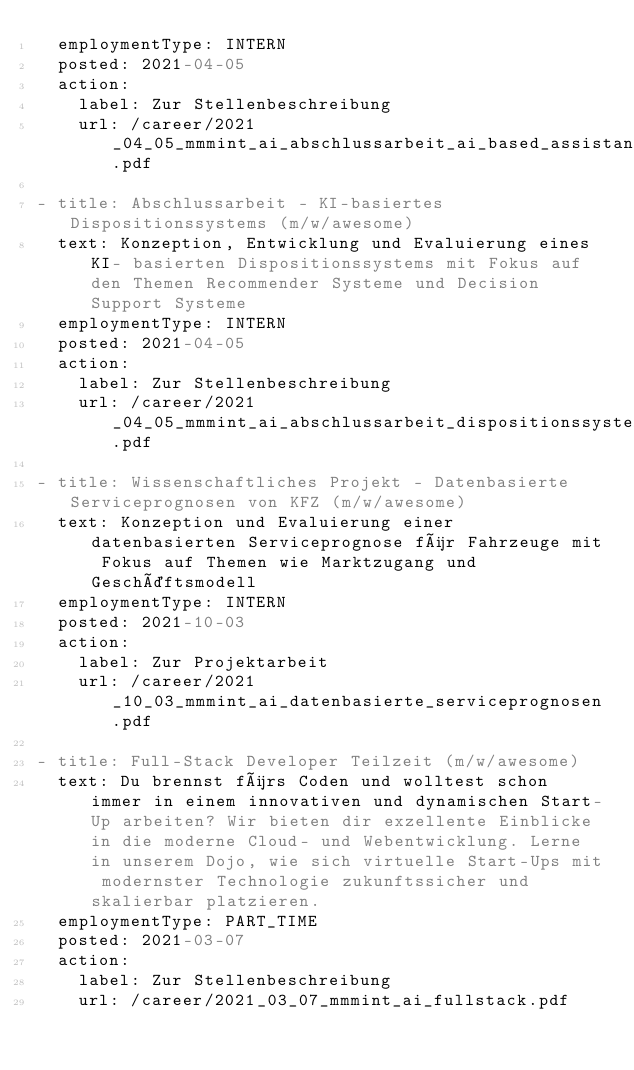Convert code to text. <code><loc_0><loc_0><loc_500><loc_500><_YAML_>  employmentType: INTERN
  posted: 2021-04-05
  action:
    label: Zur Stellenbeschreibung 
    url: /career/2021_04_05_mmmint_ai_abschlussarbeit_ai_based_assistant_systems.pdf
    
- title: Abschlussarbeit - KI-basiertes Dispositionssystems (m/w/awesome)
  text: Konzeption, Entwicklung und Evaluierung eines KI- basierten Dispositionssystems mit Fokus auf den Themen Recommender Systeme und Decision Support Systeme
  employmentType: INTERN
  posted: 2021-04-05
  action:
    label: Zur Stellenbeschreibung 
    url: /career/2021_04_05_mmmint_ai_abschlussarbeit_dispositionssystem.pdf
    
- title: Wissenschaftliches Projekt - Datenbasierte Serviceprognosen von KFZ (m/w/awesome)
  text: Konzeption und Evaluierung einer datenbasierten Serviceprognose für Fahrzeuge mit Fokus auf Themen wie Marktzugang und Geschäftsmodell
  employmentType: INTERN
  posted: 2021-10-03
  action:
    label: Zur Projektarbeit 
    url: /career/2021_10_03_mmmint_ai_datenbasierte_serviceprognosen.pdf

- title: Full-Stack Developer Teilzeit (m/w/awesome)
  text: Du brennst fürs Coden und wolltest schon immer in einem innovativen und dynamischen Start-Up arbeiten? Wir bieten dir exzellente Einblicke in die moderne Cloud- und Webentwicklung. Lerne in unserem Dojo, wie sich virtuelle Start-Ups mit modernster Technologie zukunftssicher und skalierbar platzieren.
  employmentType: PART_TIME
  posted: 2021-03-07
  action:
    label: Zur Stellenbeschreibung
    url: /career/2021_03_07_mmmint_ai_fullstack.pdf
</code> 